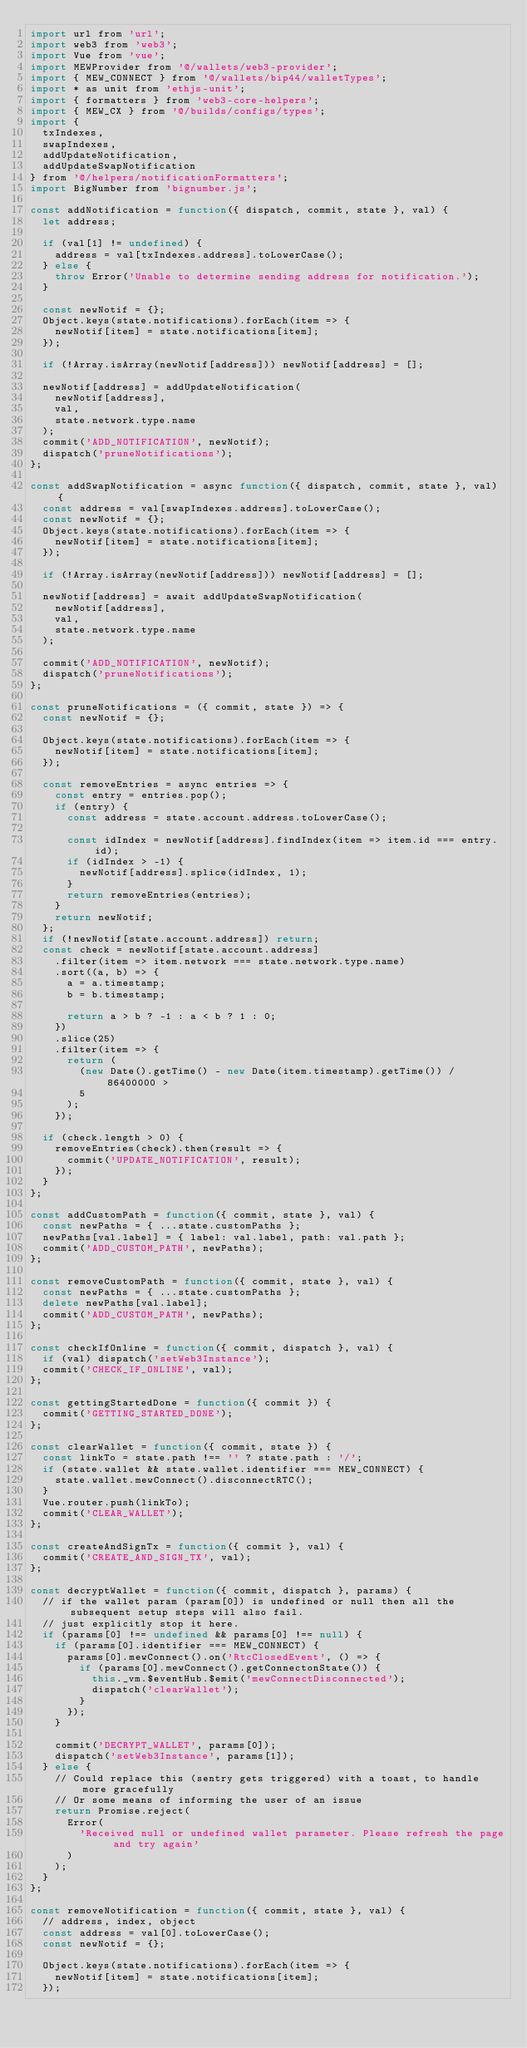Convert code to text. <code><loc_0><loc_0><loc_500><loc_500><_JavaScript_>import url from 'url';
import web3 from 'web3';
import Vue from 'vue';
import MEWProvider from '@/wallets/web3-provider';
import { MEW_CONNECT } from '@/wallets/bip44/walletTypes';
import * as unit from 'ethjs-unit';
import { formatters } from 'web3-core-helpers';
import { MEW_CX } from '@/builds/configs/types';
import {
  txIndexes,
  swapIndexes,
  addUpdateNotification,
  addUpdateSwapNotification
} from '@/helpers/notificationFormatters';
import BigNumber from 'bignumber.js';

const addNotification = function({ dispatch, commit, state }, val) {
  let address;

  if (val[1] != undefined) {
    address = val[txIndexes.address].toLowerCase();
  } else {
    throw Error('Unable to determine sending address for notification.');
  }

  const newNotif = {};
  Object.keys(state.notifications).forEach(item => {
    newNotif[item] = state.notifications[item];
  });

  if (!Array.isArray(newNotif[address])) newNotif[address] = [];

  newNotif[address] = addUpdateNotification(
    newNotif[address],
    val,
    state.network.type.name
  );
  commit('ADD_NOTIFICATION', newNotif);
  dispatch('pruneNotifications');
};

const addSwapNotification = async function({ dispatch, commit, state }, val) {
  const address = val[swapIndexes.address].toLowerCase();
  const newNotif = {};
  Object.keys(state.notifications).forEach(item => {
    newNotif[item] = state.notifications[item];
  });

  if (!Array.isArray(newNotif[address])) newNotif[address] = [];

  newNotif[address] = await addUpdateSwapNotification(
    newNotif[address],
    val,
    state.network.type.name
  );

  commit('ADD_NOTIFICATION', newNotif);
  dispatch('pruneNotifications');
};

const pruneNotifications = ({ commit, state }) => {
  const newNotif = {};

  Object.keys(state.notifications).forEach(item => {
    newNotif[item] = state.notifications[item];
  });

  const removeEntries = async entries => {
    const entry = entries.pop();
    if (entry) {
      const address = state.account.address.toLowerCase();

      const idIndex = newNotif[address].findIndex(item => item.id === entry.id);
      if (idIndex > -1) {
        newNotif[address].splice(idIndex, 1);
      }
      return removeEntries(entries);
    }
    return newNotif;
  };
  if (!newNotif[state.account.address]) return;
  const check = newNotif[state.account.address]
    .filter(item => item.network === state.network.type.name)
    .sort((a, b) => {
      a = a.timestamp;
      b = b.timestamp;

      return a > b ? -1 : a < b ? 1 : 0;
    })
    .slice(25)
    .filter(item => {
      return (
        (new Date().getTime() - new Date(item.timestamp).getTime()) / 86400000 >
        5
      );
    });

  if (check.length > 0) {
    removeEntries(check).then(result => {
      commit('UPDATE_NOTIFICATION', result);
    });
  }
};

const addCustomPath = function({ commit, state }, val) {
  const newPaths = { ...state.customPaths };
  newPaths[val.label] = { label: val.label, path: val.path };
  commit('ADD_CUSTOM_PATH', newPaths);
};

const removeCustomPath = function({ commit, state }, val) {
  const newPaths = { ...state.customPaths };
  delete newPaths[val.label];
  commit('ADD_CUSTOM_PATH', newPaths);
};

const checkIfOnline = function({ commit, dispatch }, val) {
  if (val) dispatch('setWeb3Instance');
  commit('CHECK_IF_ONLINE', val);
};

const gettingStartedDone = function({ commit }) {
  commit('GETTING_STARTED_DONE');
};

const clearWallet = function({ commit, state }) {
  const linkTo = state.path !== '' ? state.path : '/';
  if (state.wallet && state.wallet.identifier === MEW_CONNECT) {
    state.wallet.mewConnect().disconnectRTC();
  }
  Vue.router.push(linkTo);
  commit('CLEAR_WALLET');
};

const createAndSignTx = function({ commit }, val) {
  commit('CREATE_AND_SIGN_TX', val);
};

const decryptWallet = function({ commit, dispatch }, params) {
  // if the wallet param (param[0]) is undefined or null then all the subsequent setup steps will also fail.
  // just explicitly stop it here.
  if (params[0] !== undefined && params[0] !== null) {
    if (params[0].identifier === MEW_CONNECT) {
      params[0].mewConnect().on('RtcClosedEvent', () => {
        if (params[0].mewConnect().getConnectonState()) {
          this._vm.$eventHub.$emit('mewConnectDisconnected');
          dispatch('clearWallet');
        }
      });
    }

    commit('DECRYPT_WALLET', params[0]);
    dispatch('setWeb3Instance', params[1]);
  } else {
    // Could replace this (sentry gets triggered) with a toast, to handle more gracefully
    // Or some means of informing the user of an issue
    return Promise.reject(
      Error(
        'Received null or undefined wallet parameter. Please refresh the page and try again'
      )
    );
  }
};

const removeNotification = function({ commit, state }, val) {
  // address, index, object
  const address = val[0].toLowerCase();
  const newNotif = {};

  Object.keys(state.notifications).forEach(item => {
    newNotif[item] = state.notifications[item];
  });
</code> 